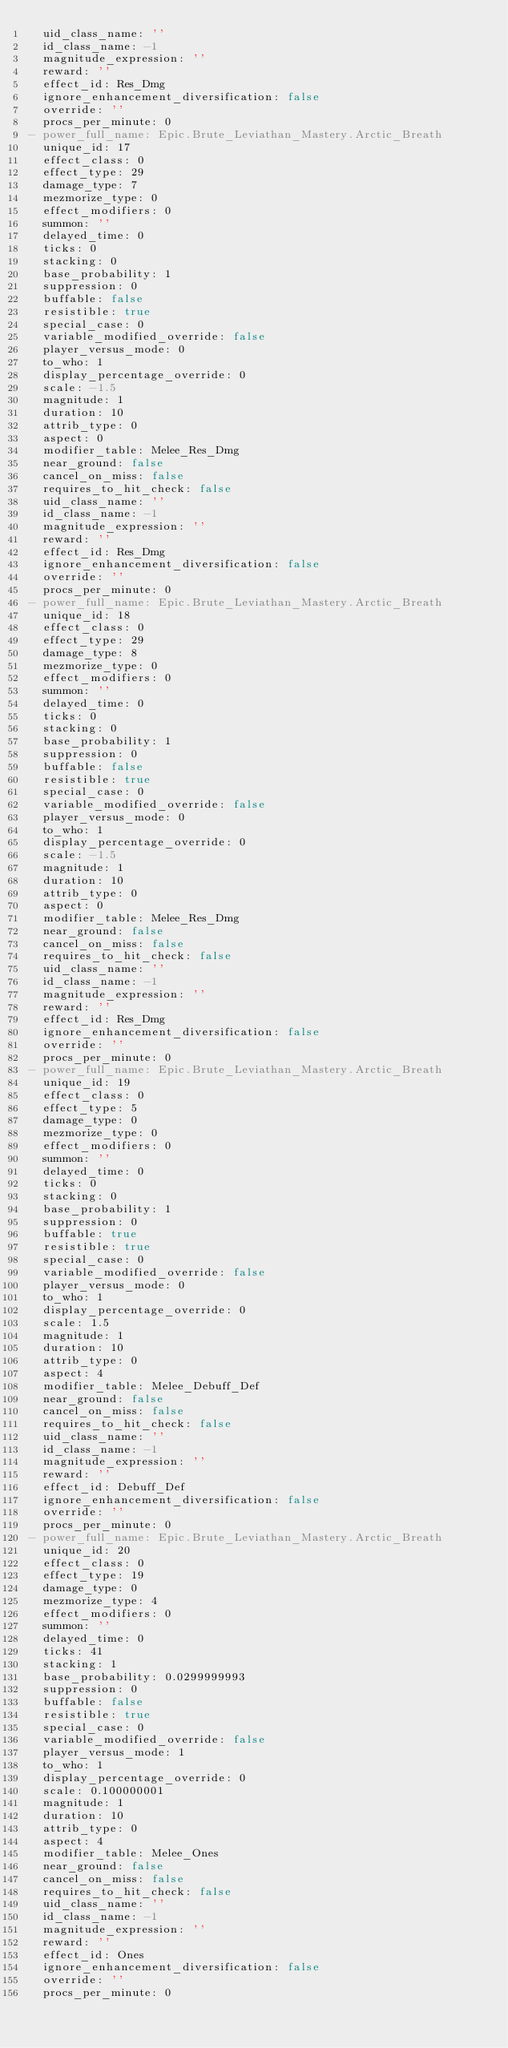Convert code to text. <code><loc_0><loc_0><loc_500><loc_500><_YAML_>  uid_class_name: ''
  id_class_name: -1
  magnitude_expression: ''
  reward: ''
  effect_id: Res_Dmg
  ignore_enhancement_diversification: false
  override: ''
  procs_per_minute: 0
- power_full_name: Epic.Brute_Leviathan_Mastery.Arctic_Breath
  unique_id: 17
  effect_class: 0
  effect_type: 29
  damage_type: 7
  mezmorize_type: 0
  effect_modifiers: 0
  summon: ''
  delayed_time: 0
  ticks: 0
  stacking: 0
  base_probability: 1
  suppression: 0
  buffable: false
  resistible: true
  special_case: 0
  variable_modified_override: false
  player_versus_mode: 0
  to_who: 1
  display_percentage_override: 0
  scale: -1.5
  magnitude: 1
  duration: 10
  attrib_type: 0
  aspect: 0
  modifier_table: Melee_Res_Dmg
  near_ground: false
  cancel_on_miss: false
  requires_to_hit_check: false
  uid_class_name: ''
  id_class_name: -1
  magnitude_expression: ''
  reward: ''
  effect_id: Res_Dmg
  ignore_enhancement_diversification: false
  override: ''
  procs_per_minute: 0
- power_full_name: Epic.Brute_Leviathan_Mastery.Arctic_Breath
  unique_id: 18
  effect_class: 0
  effect_type: 29
  damage_type: 8
  mezmorize_type: 0
  effect_modifiers: 0
  summon: ''
  delayed_time: 0
  ticks: 0
  stacking: 0
  base_probability: 1
  suppression: 0
  buffable: false
  resistible: true
  special_case: 0
  variable_modified_override: false
  player_versus_mode: 0
  to_who: 1
  display_percentage_override: 0
  scale: -1.5
  magnitude: 1
  duration: 10
  attrib_type: 0
  aspect: 0
  modifier_table: Melee_Res_Dmg
  near_ground: false
  cancel_on_miss: false
  requires_to_hit_check: false
  uid_class_name: ''
  id_class_name: -1
  magnitude_expression: ''
  reward: ''
  effect_id: Res_Dmg
  ignore_enhancement_diversification: false
  override: ''
  procs_per_minute: 0
- power_full_name: Epic.Brute_Leviathan_Mastery.Arctic_Breath
  unique_id: 19
  effect_class: 0
  effect_type: 5
  damage_type: 0
  mezmorize_type: 0
  effect_modifiers: 0
  summon: ''
  delayed_time: 0
  ticks: 0
  stacking: 0
  base_probability: 1
  suppression: 0
  buffable: true
  resistible: true
  special_case: 0
  variable_modified_override: false
  player_versus_mode: 0
  to_who: 1
  display_percentage_override: 0
  scale: 1.5
  magnitude: 1
  duration: 10
  attrib_type: 0
  aspect: 4
  modifier_table: Melee_Debuff_Def
  near_ground: false
  cancel_on_miss: false
  requires_to_hit_check: false
  uid_class_name: ''
  id_class_name: -1
  magnitude_expression: ''
  reward: ''
  effect_id: Debuff_Def
  ignore_enhancement_diversification: false
  override: ''
  procs_per_minute: 0
- power_full_name: Epic.Brute_Leviathan_Mastery.Arctic_Breath
  unique_id: 20
  effect_class: 0
  effect_type: 19
  damage_type: 0
  mezmorize_type: 4
  effect_modifiers: 0
  summon: ''
  delayed_time: 0
  ticks: 41
  stacking: 1
  base_probability: 0.0299999993
  suppression: 0
  buffable: false
  resistible: true
  special_case: 0
  variable_modified_override: false
  player_versus_mode: 1
  to_who: 1
  display_percentage_override: 0
  scale: 0.100000001
  magnitude: 1
  duration: 10
  attrib_type: 0
  aspect: 4
  modifier_table: Melee_Ones
  near_ground: false
  cancel_on_miss: false
  requires_to_hit_check: false
  uid_class_name: ''
  id_class_name: -1
  magnitude_expression: ''
  reward: ''
  effect_id: Ones
  ignore_enhancement_diversification: false
  override: ''
  procs_per_minute: 0</code> 